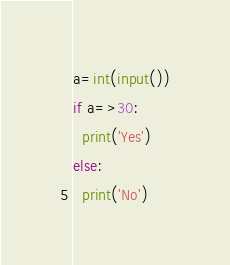Convert code to text. <code><loc_0><loc_0><loc_500><loc_500><_Python_>a=int(input())
if a=>30:
  print('Yes')
else:
  print('No')</code> 